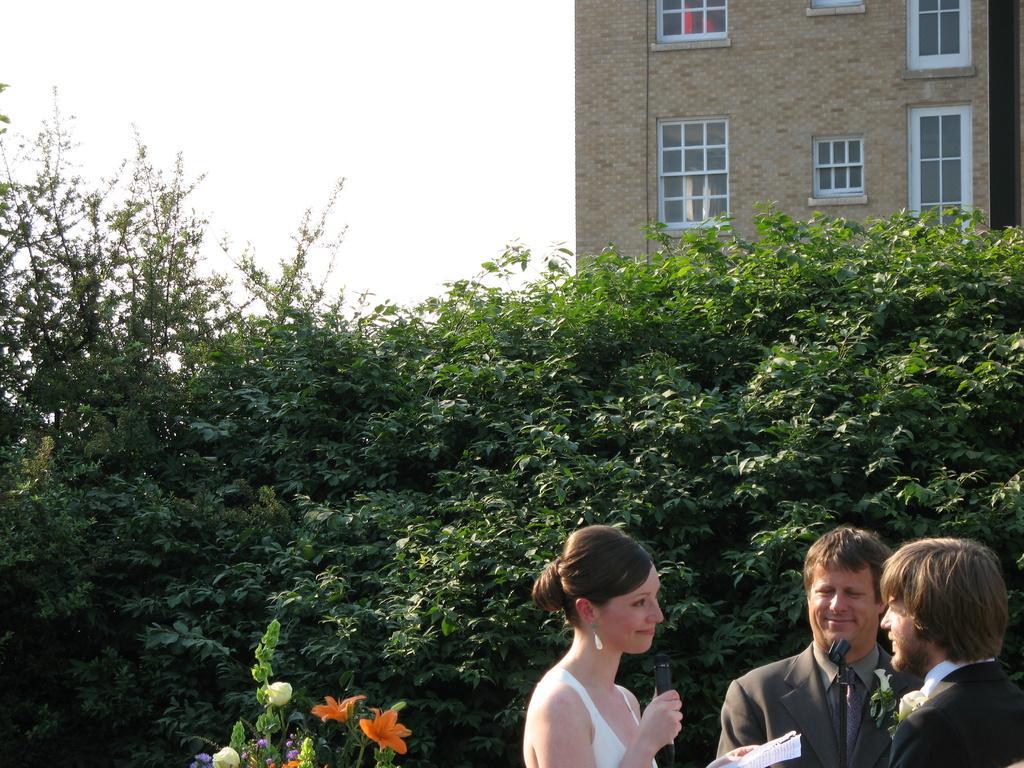Can you describe this image briefly? In the bottom right corner of the image three persons are standing. Behind them there are some flowers and trees. In the top right corner of the image there is a building. In the top left corner of the image there is sky. 